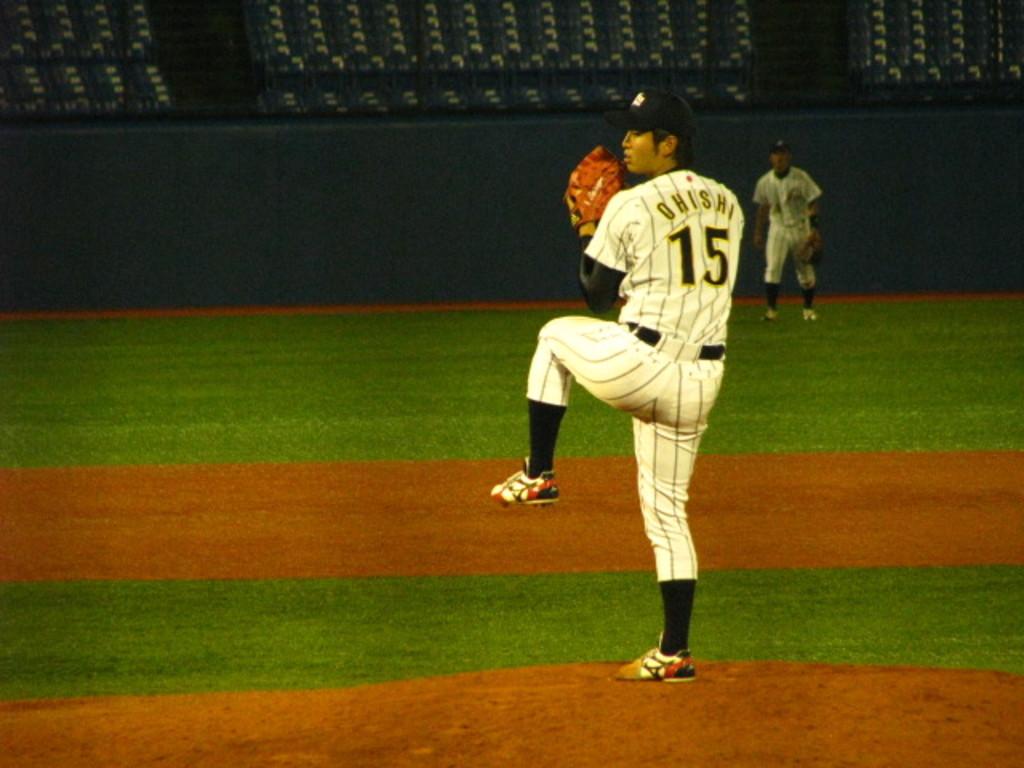What is this player's name?
Offer a very short reply. Ohishi. 